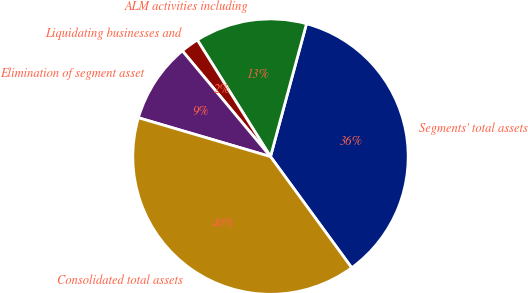<chart> <loc_0><loc_0><loc_500><loc_500><pie_chart><fcel>Segments' total assets<fcel>ALM activities including<fcel>Liquidating businesses and<fcel>Elimination of segment asset<fcel>Consolidated total assets<nl><fcel>35.75%<fcel>13.13%<fcel>2.14%<fcel>9.39%<fcel>39.6%<nl></chart> 